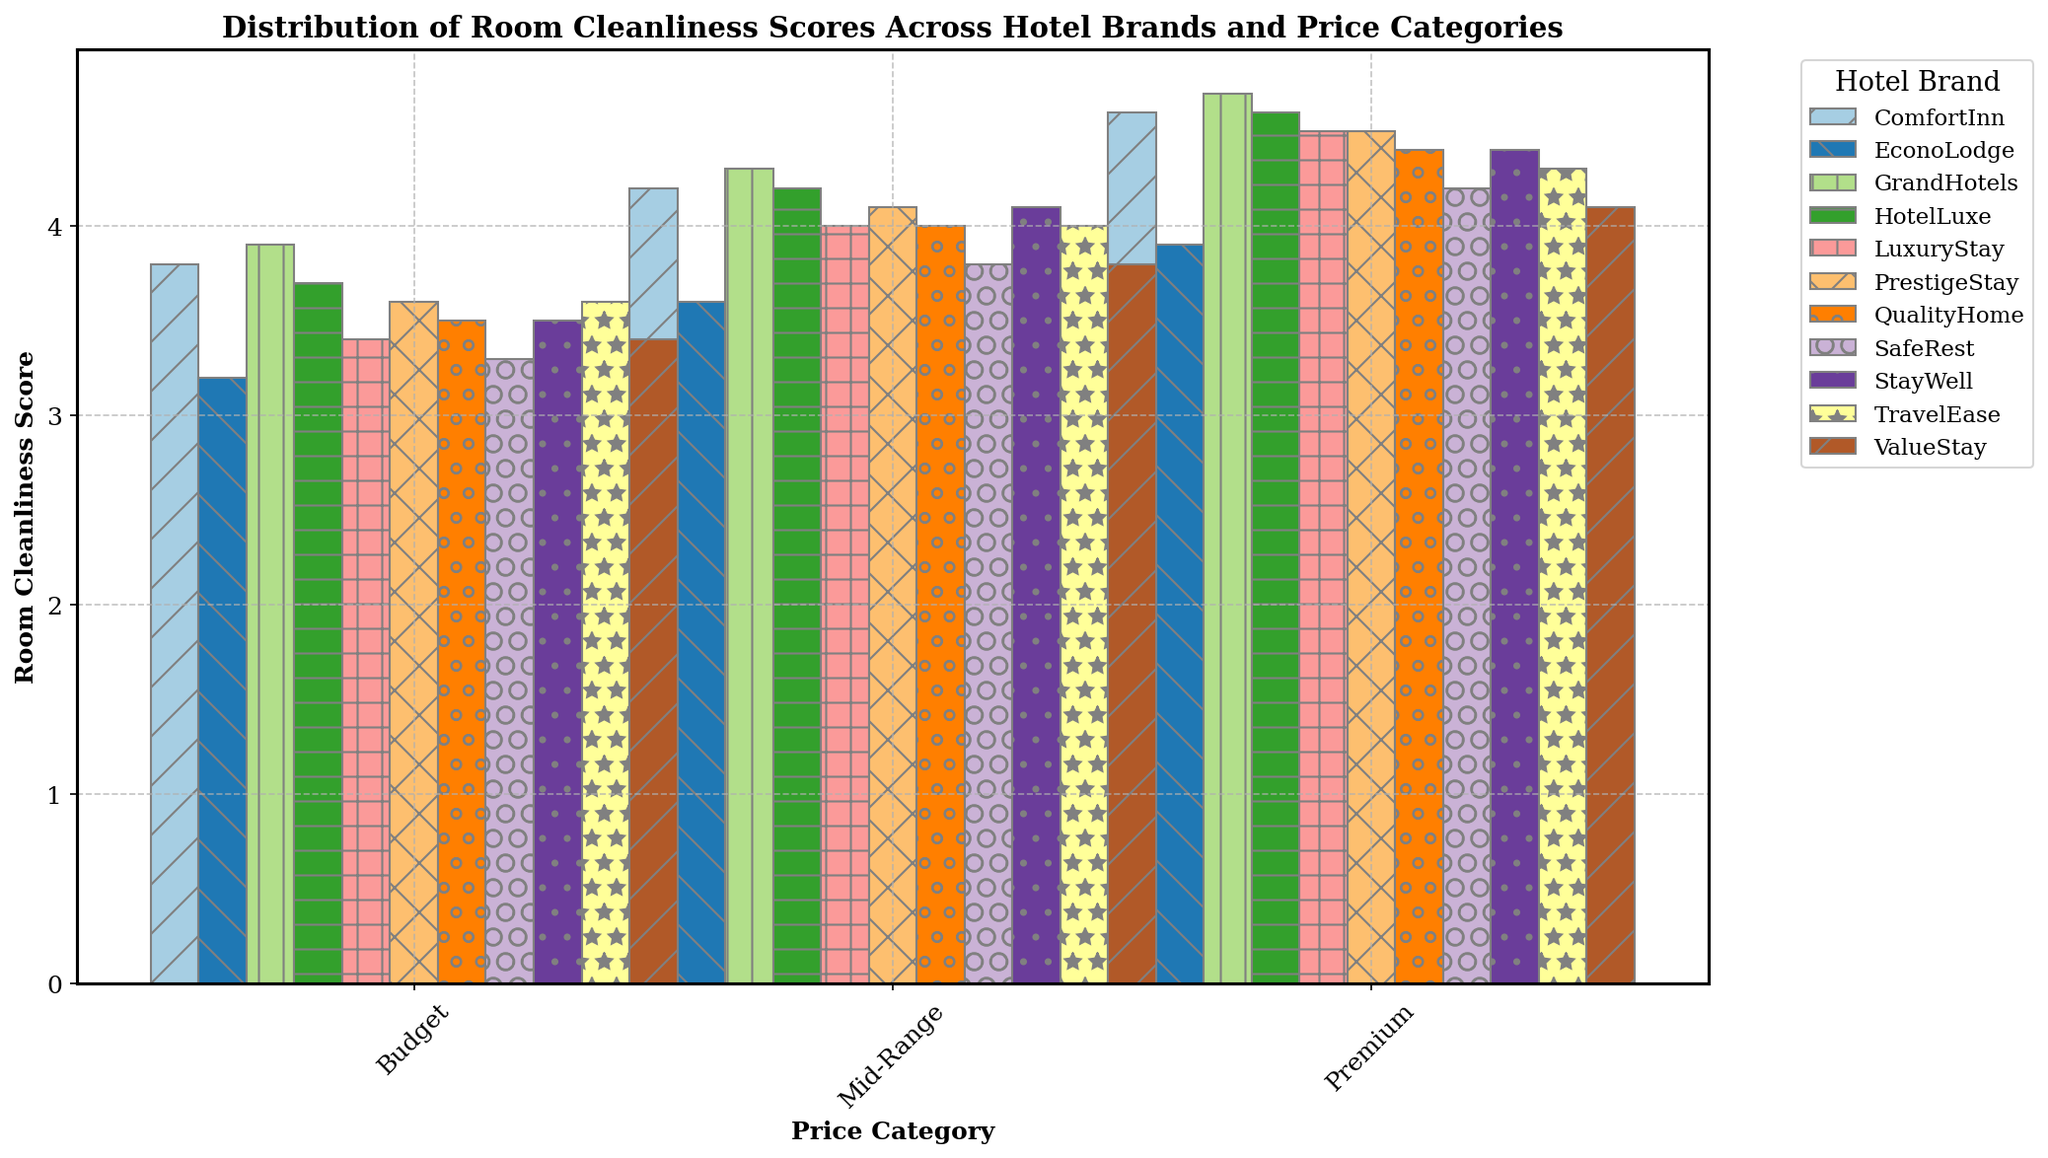Which hotel brand has the highest Room Cleanliness Score in the Premium price category? To determine which hotel brand has the highest Room Cleanliness Score in the Premium category, look at the height of the bars within the Premium group for all brands. The tallest bar indicates the highest score.
Answer: GrandHotels Which hotel brand has the lowest Room Cleanliness Score in the Budget price category? To find the lowest score in the Budget price category, compare the heights of the bars labeled Budget across all brands. The brand with the shortest bar has the lowest score.
Answer: EconoLodge What is the difference in Room Cleanliness Score between ComfortInn and ValueStay in the Mid-Range price category? Locate the bars for ComfortInn and ValueStay in the Mid-Range category. Note their scores (ComfortInn: 4.2, ValueStay: 3.8). Subtract the ValueStay score from the ComfortInn score.
Answer: 0.4 Which hotel brand shows the most improvement in Room Cleanliness Score from Budget to Premium price category? To find the most improvement, calculate the difference in Room Cleanliness Score between Budget and Premium for each brand. The brand with the largest increase is the one with the most improvement.
Answer: GrandHotels On average, which price category has the highest Room Cleanliness Score across all hotel brands? Calculate the average Room Cleanliness Score for each price category by summing the scores in each category and dividing by the number of hotel brands (10). Compare these averages to determine which category has the highest.
Answer: Premium Between TravelEase and HotelLuxe, which brand has a higher average Room Cleanliness Score across all price categories? For each brand (TravelEase and HotelLuxe), calculate the average score by adding the scores for all three price categories and dividing by 3. Compare these averages.
Answer: HotelLuxe What is the total Room Cleanliness Score for StayWell across all price categories? Add the Room Cleanliness Scores for StayWell in the Budget, Mid-Range, and Premium categories (3.5, 4.1, and 4.4).
Answer: 12.0 Which hotel brand has the most consistent Room Cleanliness Scores across all price categories (i.e., the smallest range between highest and lowest scores)? Calculate the range (difference between highest and lowest scores) for each hotel brand across all price categories. The brand with the smallest range is the most consistent.
Answer: TravelEase 